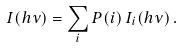<formula> <loc_0><loc_0><loc_500><loc_500>I ( h \nu ) = \sum _ { i } P ( i ) \, I _ { i } ( h \nu ) \, .</formula> 